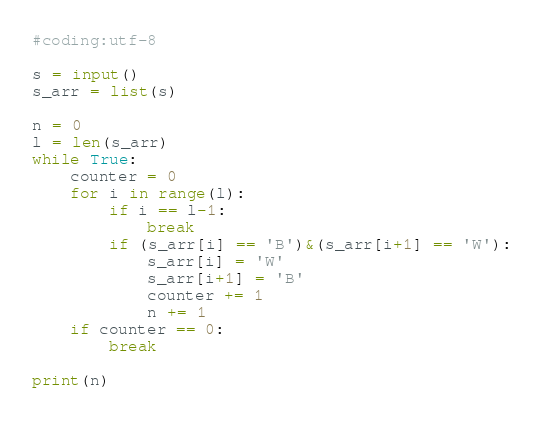<code> <loc_0><loc_0><loc_500><loc_500><_Python_>#coding:utf-8

s = input()
s_arr = list(s)

n = 0
l = len(s_arr)
while True:
    counter = 0
    for i in range(l):
        if i == l-1:
            break
        if (s_arr[i] == 'B')&(s_arr[i+1] == 'W'):
            s_arr[i] = 'W'
            s_arr[i+1] = 'B'
            counter += 1
            n += 1
    if counter == 0:
        break

print(n)</code> 